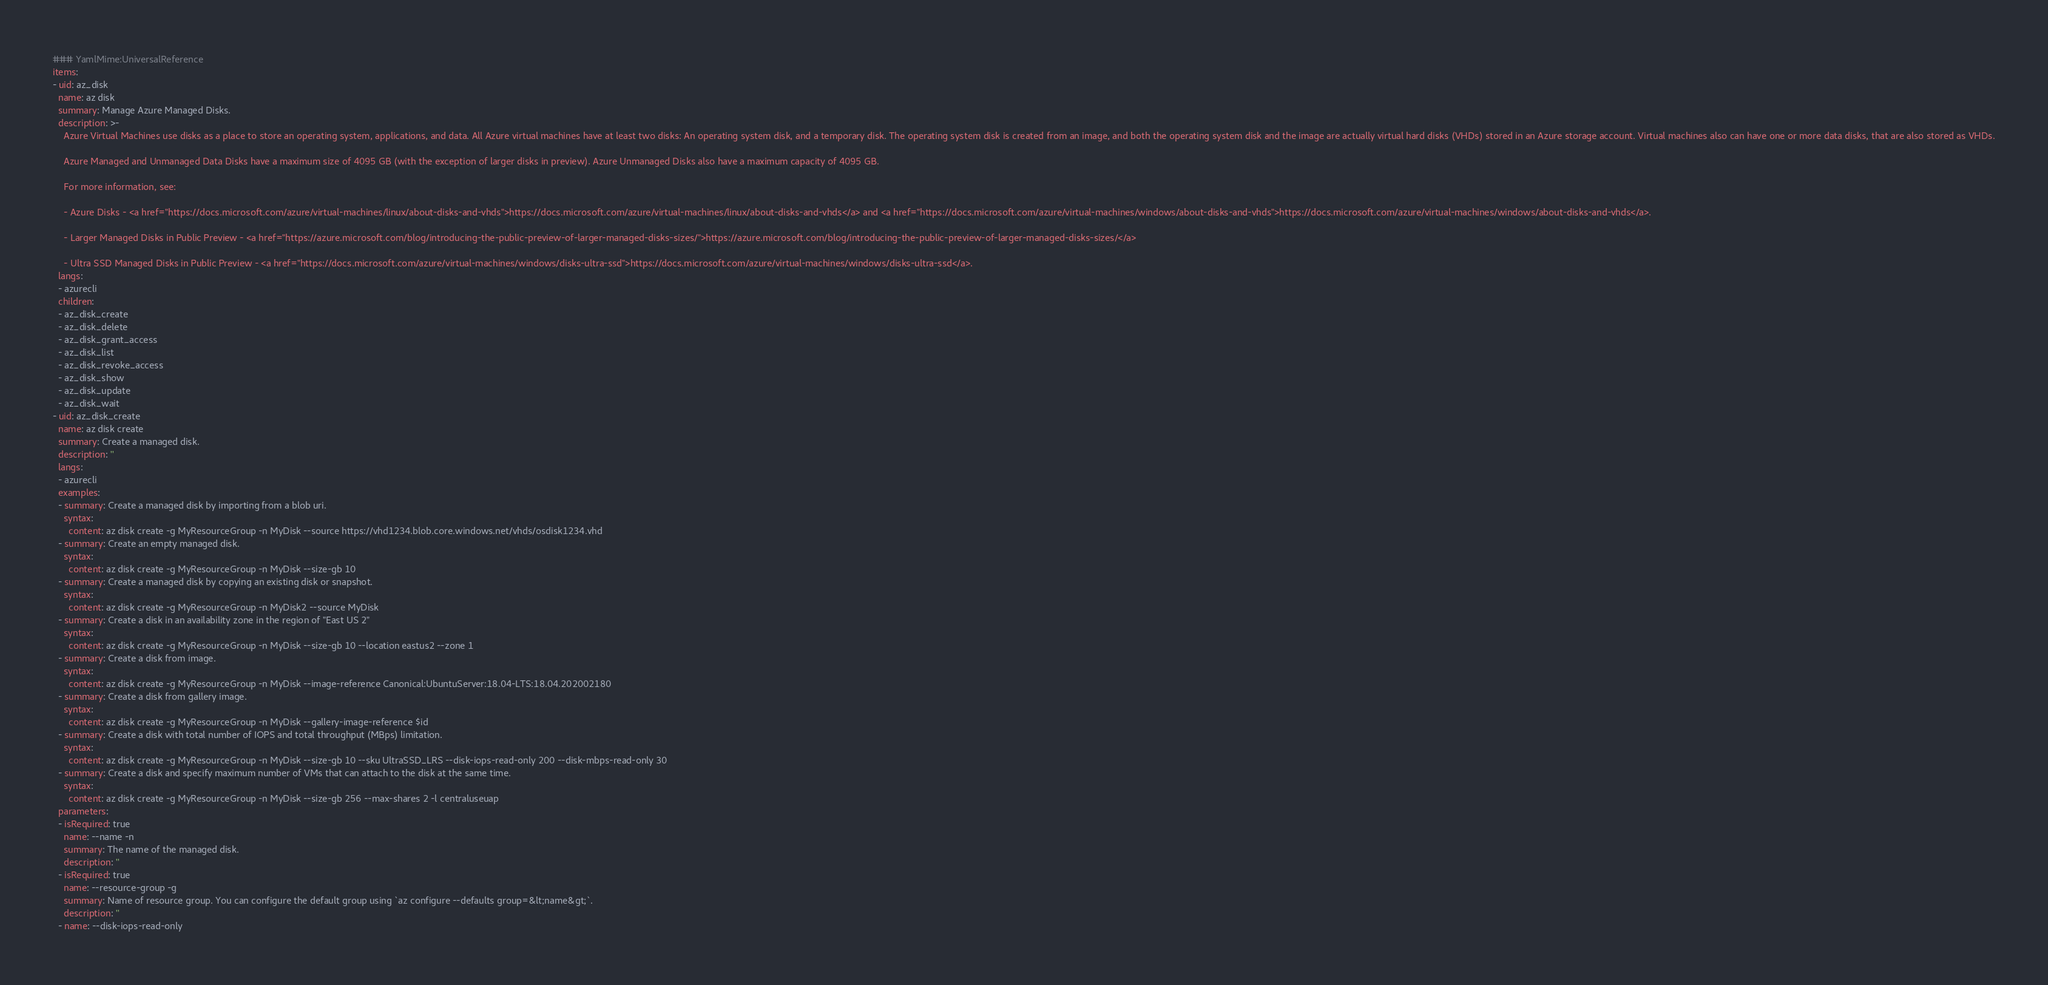<code> <loc_0><loc_0><loc_500><loc_500><_YAML_>### YamlMime:UniversalReference
items:
- uid: az_disk
  name: az disk
  summary: Manage Azure Managed Disks.
  description: >-
    Azure Virtual Machines use disks as a place to store an operating system, applications, and data. All Azure virtual machines have at least two disks: An operating system disk, and a temporary disk. The operating system disk is created from an image, and both the operating system disk and the image are actually virtual hard disks (VHDs) stored in an Azure storage account. Virtual machines also can have one or more data disks, that are also stored as VHDs.

    Azure Managed and Unmanaged Data Disks have a maximum size of 4095 GB (with the exception of larger disks in preview). Azure Unmanaged Disks also have a maximum capacity of 4095 GB.

    For more information, see:

    - Azure Disks - <a href="https://docs.microsoft.com/azure/virtual-machines/linux/about-disks-and-vhds">https://docs.microsoft.com/azure/virtual-machines/linux/about-disks-and-vhds</a> and <a href="https://docs.microsoft.com/azure/virtual-machines/windows/about-disks-and-vhds">https://docs.microsoft.com/azure/virtual-machines/windows/about-disks-and-vhds</a>.

    - Larger Managed Disks in Public Preview - <a href="https://azure.microsoft.com/blog/introducing-the-public-preview-of-larger-managed-disks-sizes/">https://azure.microsoft.com/blog/introducing-the-public-preview-of-larger-managed-disks-sizes/</a>

    - Ultra SSD Managed Disks in Public Preview - <a href="https://docs.microsoft.com/azure/virtual-machines/windows/disks-ultra-ssd">https://docs.microsoft.com/azure/virtual-machines/windows/disks-ultra-ssd</a>.
  langs:
  - azurecli
  children:
  - az_disk_create
  - az_disk_delete
  - az_disk_grant_access
  - az_disk_list
  - az_disk_revoke_access
  - az_disk_show
  - az_disk_update
  - az_disk_wait
- uid: az_disk_create
  name: az disk create
  summary: Create a managed disk.
  description: ''
  langs:
  - azurecli
  examples:
  - summary: Create a managed disk by importing from a blob uri.
    syntax:
      content: az disk create -g MyResourceGroup -n MyDisk --source https://vhd1234.blob.core.windows.net/vhds/osdisk1234.vhd
  - summary: Create an empty managed disk.
    syntax:
      content: az disk create -g MyResourceGroup -n MyDisk --size-gb 10
  - summary: Create a managed disk by copying an existing disk or snapshot.
    syntax:
      content: az disk create -g MyResourceGroup -n MyDisk2 --source MyDisk
  - summary: Create a disk in an availability zone in the region of "East US 2"
    syntax:
      content: az disk create -g MyResourceGroup -n MyDisk --size-gb 10 --location eastus2 --zone 1
  - summary: Create a disk from image.
    syntax:
      content: az disk create -g MyResourceGroup -n MyDisk --image-reference Canonical:UbuntuServer:18.04-LTS:18.04.202002180
  - summary: Create a disk from gallery image.
    syntax:
      content: az disk create -g MyResourceGroup -n MyDisk --gallery-image-reference $id
  - summary: Create a disk with total number of IOPS and total throughput (MBps) limitation.
    syntax:
      content: az disk create -g MyResourceGroup -n MyDisk --size-gb 10 --sku UltraSSD_LRS --disk-iops-read-only 200 --disk-mbps-read-only 30
  - summary: Create a disk and specify maximum number of VMs that can attach to the disk at the same time.
    syntax:
      content: az disk create -g MyResourceGroup -n MyDisk --size-gb 256 --max-shares 2 -l centraluseuap
  parameters:
  - isRequired: true
    name: --name -n
    summary: The name of the managed disk.
    description: ''
  - isRequired: true
    name: --resource-group -g
    summary: Name of resource group. You can configure the default group using `az configure --defaults group=&lt;name&gt;`.
    description: ''
  - name: --disk-iops-read-only</code> 